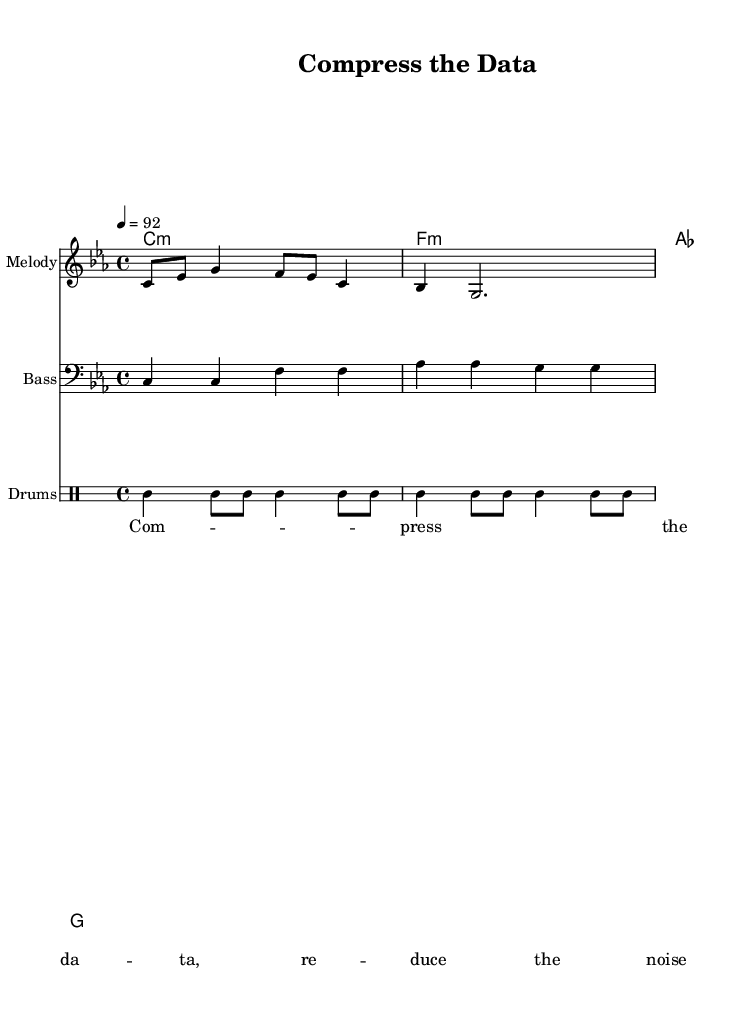What is the key signature of this music? The key signature is C minor, which has three flats (B♭, E♭, and A♭). This is indicated at the beginning of the sheet music.
Answer: C minor What is the time signature of the piece? The time signature is 4/4, which means there are four beats in each measure and the quarter note receives one beat. This is shown at the beginning of the music.
Answer: 4/4 What is the tempo marking? The tempo marking indicates a speed of 92 beats per minute, which tells performers how fast to play the piece. This is specified in the tempo section of the score.
Answer: 92 Which instruments are featured in this score? The score contains Melody, Bass, and Drums. Each instrument is clearly labeled in the instrument name at the start of each staff.
Answer: Melody, Bass, Drums How many measures are in the melody? There are four measures in the melody, as represented by the grouping of notes and barlines across the staff. This can be counted visually from the beginning to the end of the melody section.
Answer: 4 What lyrical theme is presented in the verse? The verse presents a theme about data compression, with the lyrics focusing on reducing noise and compressing data. This is deduced from the text provided in the lyrics section.
Answer: Data compression How does this composition reflect the characteristics of rap music? This composition reflects rap characteristics through its rhythmic delivery, strong beat (from drums), and lyrical focus on a specific topic (data compression techniques), all typical of rap songs.
Answer: Rhythmic delivery and topical focus 